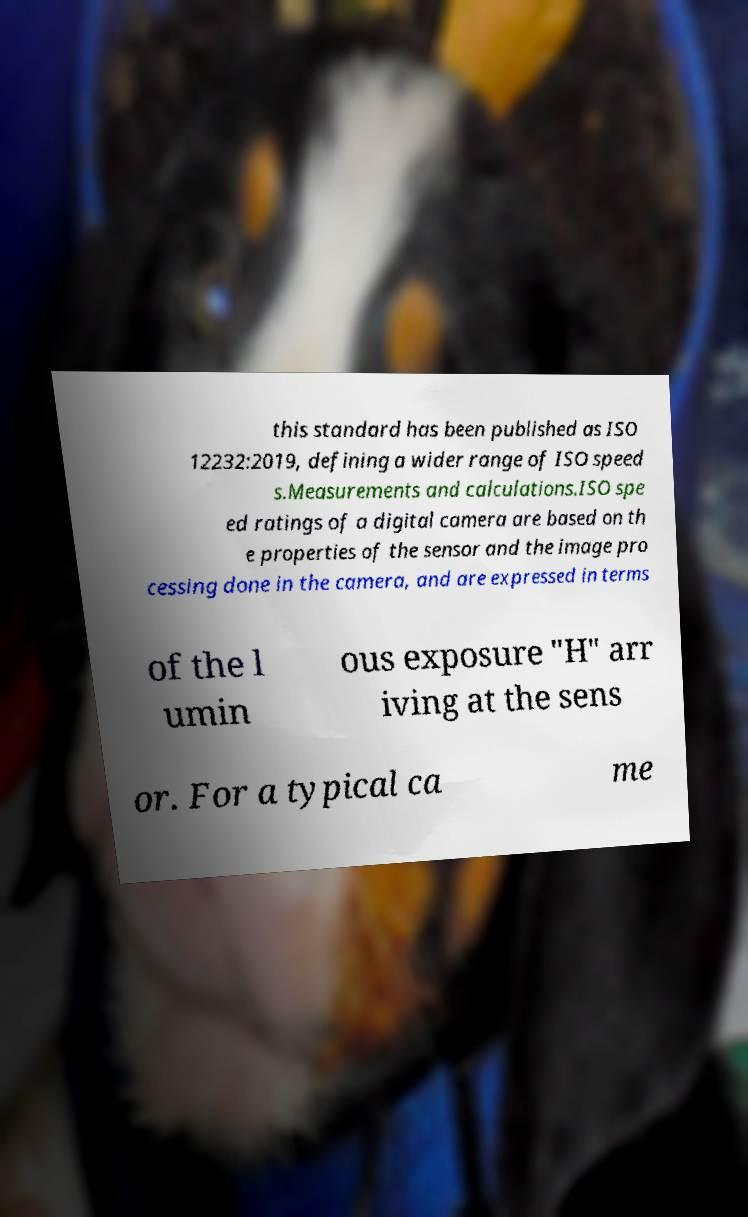Please read and relay the text visible in this image. What does it say? this standard has been published as ISO 12232:2019, defining a wider range of ISO speed s.Measurements and calculations.ISO spe ed ratings of a digital camera are based on th e properties of the sensor and the image pro cessing done in the camera, and are expressed in terms of the l umin ous exposure "H" arr iving at the sens or. For a typical ca me 